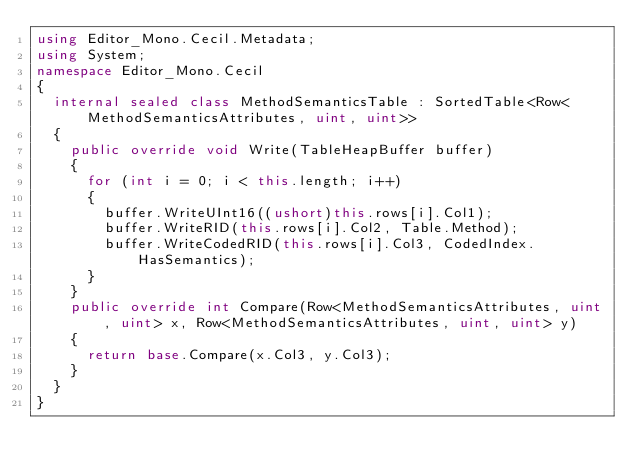Convert code to text. <code><loc_0><loc_0><loc_500><loc_500><_C#_>using Editor_Mono.Cecil.Metadata;
using System;
namespace Editor_Mono.Cecil
{
	internal sealed class MethodSemanticsTable : SortedTable<Row<MethodSemanticsAttributes, uint, uint>>
	{
		public override void Write(TableHeapBuffer buffer)
		{
			for (int i = 0; i < this.length; i++)
			{
				buffer.WriteUInt16((ushort)this.rows[i].Col1);
				buffer.WriteRID(this.rows[i].Col2, Table.Method);
				buffer.WriteCodedRID(this.rows[i].Col3, CodedIndex.HasSemantics);
			}
		}
		public override int Compare(Row<MethodSemanticsAttributes, uint, uint> x, Row<MethodSemanticsAttributes, uint, uint> y)
		{
			return base.Compare(x.Col3, y.Col3);
		}
	}
}
</code> 